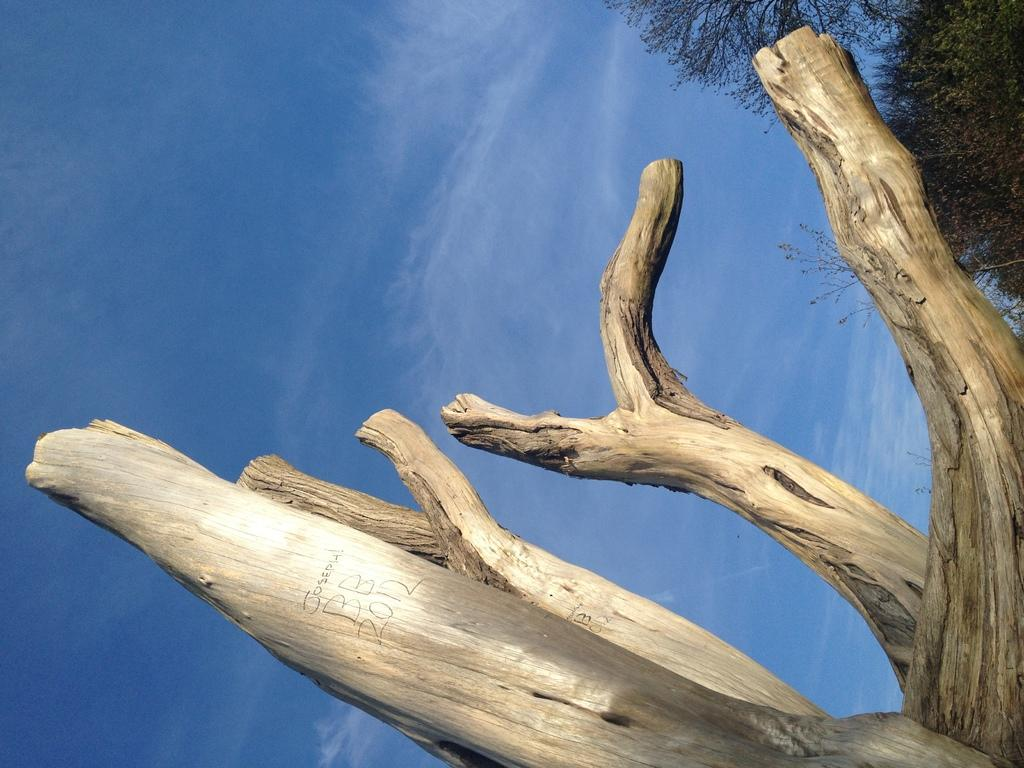What type of object is in the image? There is a wooden trunk in the image. What can be seen on the right side of the image? There are trees and plants on the right side of the image. What is visible in the background of the image? The sky is visible in the background of the image. What type of mint can be seen growing near the wooden trunk in the image? There is no mint visible in the image; only trees and plants are mentioned. How many tomatoes are hanging from the trees in the image? There is no mention of tomatoes in the image; only trees and plants are described. 